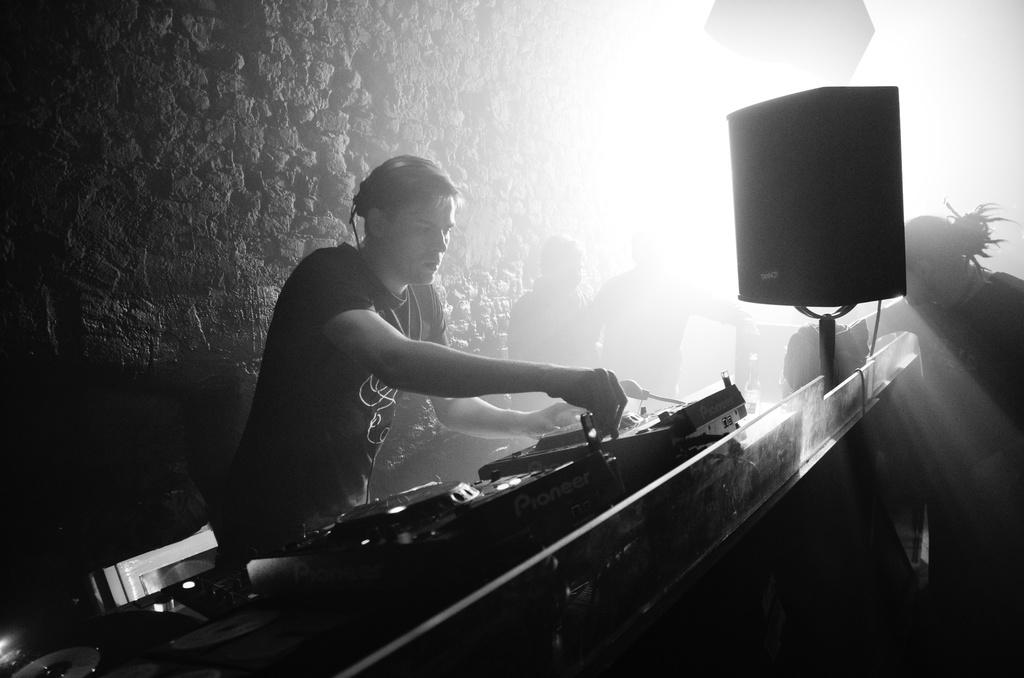What is the color scheme of the image? The image is black and white. What can be seen in the image besides the color scheme? There are people and musical instruments in the image. What is visible behind the people and musical instruments? There is a background visible in the image. What type of engine is being used to power the musical instruments in the image? There is no engine present in the image, as musical instruments do not require engines to function. 